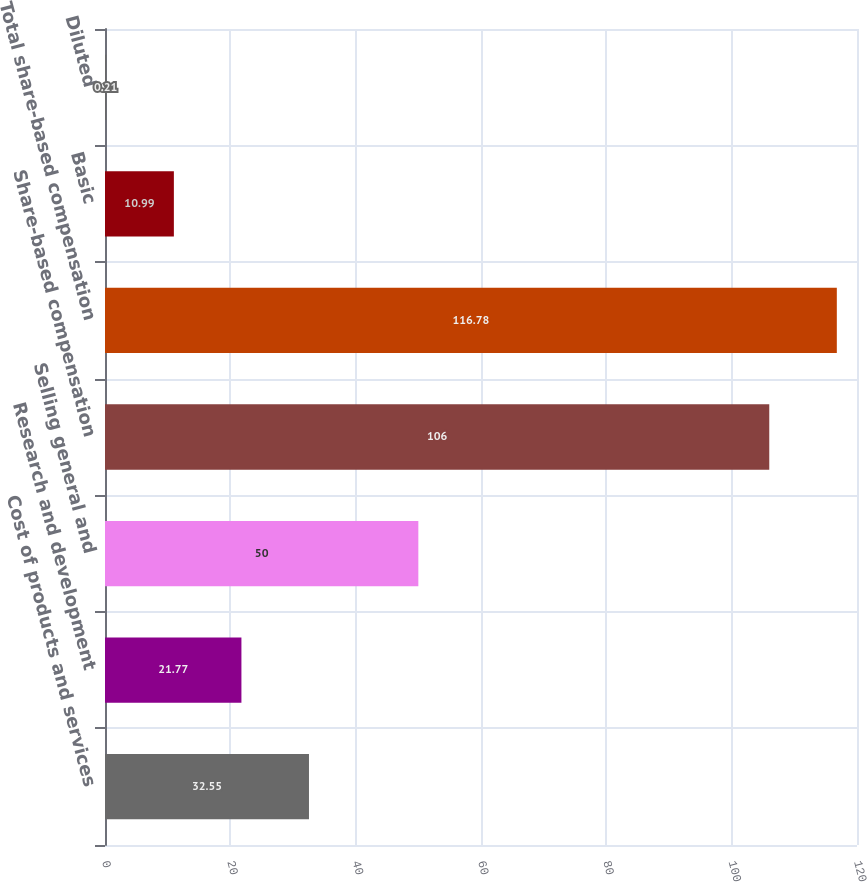<chart> <loc_0><loc_0><loc_500><loc_500><bar_chart><fcel>Cost of products and services<fcel>Research and development<fcel>Selling general and<fcel>Share-based compensation<fcel>Total share-based compensation<fcel>Basic<fcel>Diluted<nl><fcel>32.55<fcel>21.77<fcel>50<fcel>106<fcel>116.78<fcel>10.99<fcel>0.21<nl></chart> 